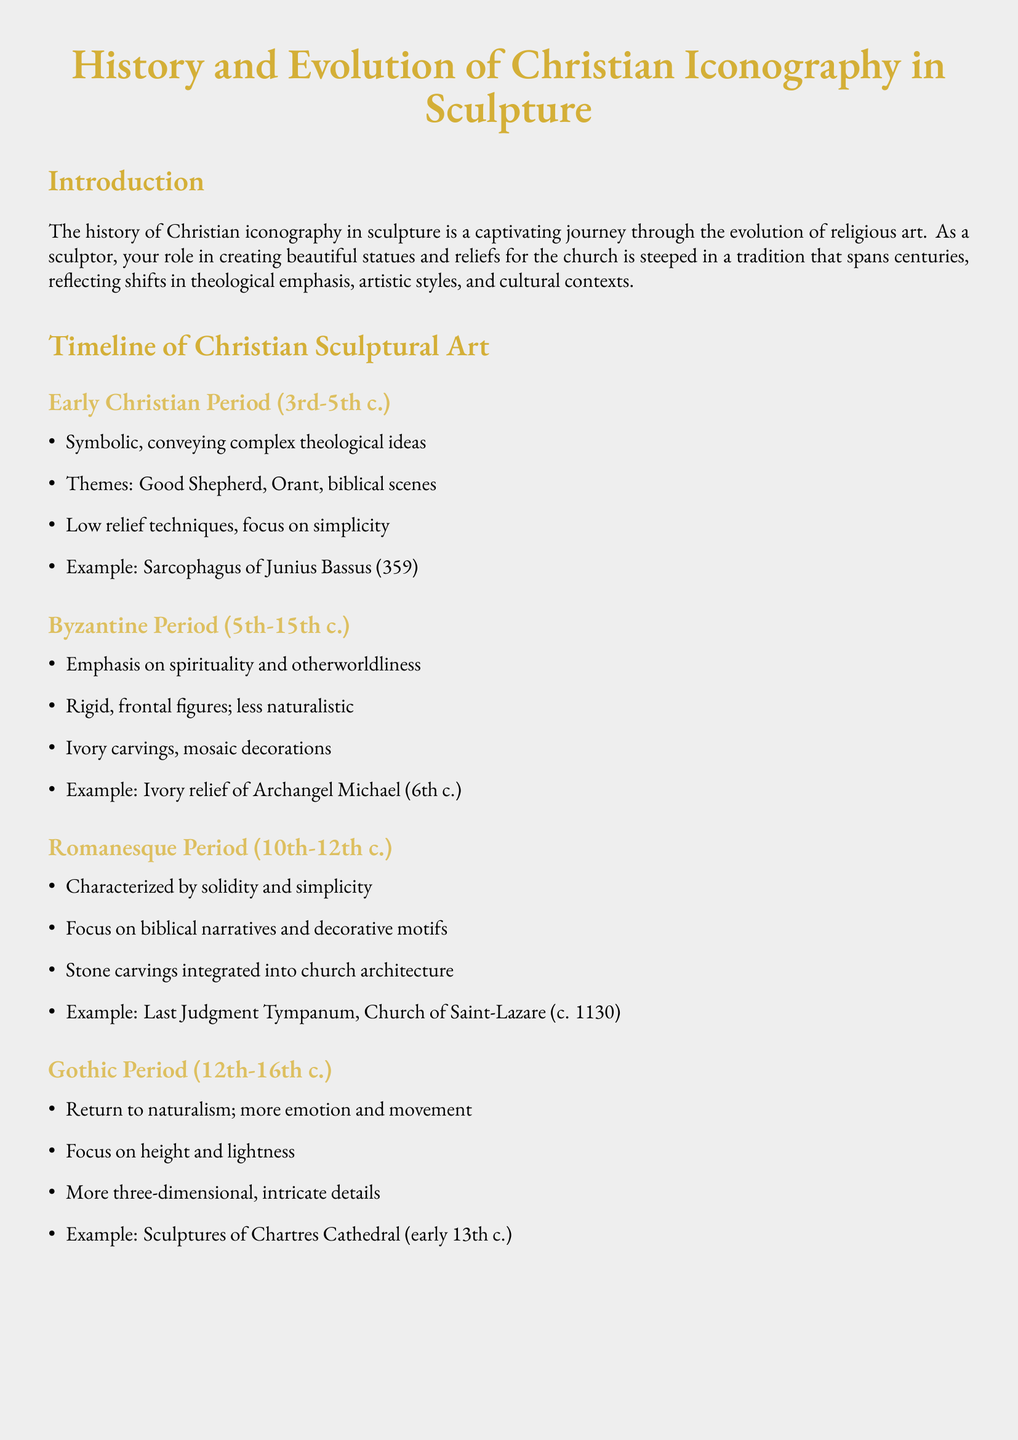What period does the Sarcophagus of Junius Bassus belong to? The Sarcophagus of Junius Bassus is mentioned as an example from the Early Christian Period (3rd-5th c.).
Answer: Early Christian Period What is a significant thematic emphasis in the Byzantine Period? The document states that the Byzantine Period emphasizes spirituality and otherworldliness.
Answer: Spirituality and otherworldliness Which period is characterized by dynamic movement and emotional intensity? The Baroque Period is described to have dynamic movement and emotional intensity.
Answer: Baroque Period What artistic technique is highlighted in Michelangelo's 'Pietà'? The document mentions anatomical precision as a technique highlighted in Michelangelo's 'Pietà'.
Answer: Anatomical precision Which church features the Last Judgment Tympanum? The document specifies that the Last Judgment Tympanum is found in the Church of Saint-Lazare.
Answer: Church of Saint-Lazare What is the primary style transition noted in the Gothic Period? The document notes a return to naturalism as the primary style transition in the Gothic Period.
Answer: Return to naturalism What type of carving is associated with the early Romanesque Period? The document states that stone carvings are integrated into church architecture during the Romanesque Period.
Answer: Stone carvings In what century was Bernini's 'The Ecstasy of Saint Teresa' created? The document indicates that Bernini's 'The Ecstasy of Saint Teresa' was created in 1652.
Answer: 1652 What technique was commonly used in the Renaissance for human representations? The document mentions the contrapposto technique as commonly used in the Renaissance.
Answer: Contrapposto 